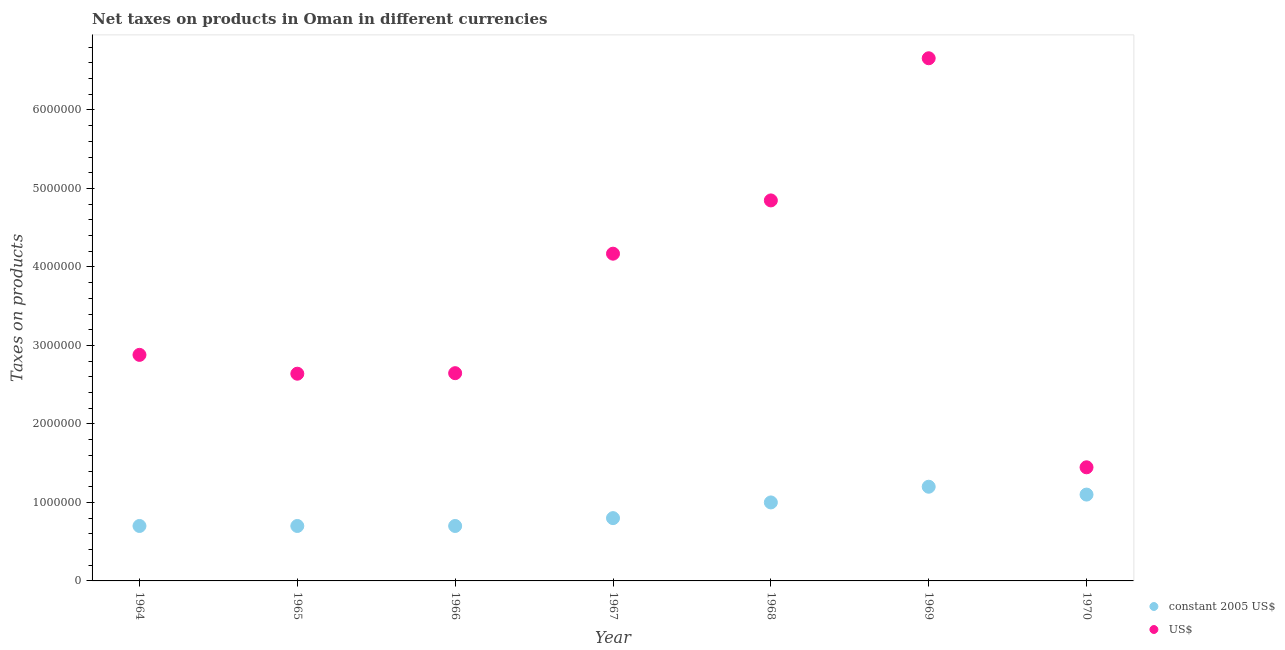Is the number of dotlines equal to the number of legend labels?
Keep it short and to the point. Yes. What is the net taxes in constant 2005 us$ in 1969?
Provide a short and direct response. 1.20e+06. Across all years, what is the maximum net taxes in constant 2005 us$?
Provide a short and direct response. 1.20e+06. Across all years, what is the minimum net taxes in us$?
Keep it short and to the point. 1.45e+06. In which year was the net taxes in constant 2005 us$ maximum?
Provide a succinct answer. 1969. In which year was the net taxes in constant 2005 us$ minimum?
Keep it short and to the point. 1964. What is the total net taxes in constant 2005 us$ in the graph?
Ensure brevity in your answer.  6.20e+06. What is the difference between the net taxes in constant 2005 us$ in 1966 and that in 1969?
Provide a succinct answer. -5.00e+05. What is the difference between the net taxes in us$ in 1968 and the net taxes in constant 2005 us$ in 1970?
Offer a terse response. 3.75e+06. What is the average net taxes in constant 2005 us$ per year?
Keep it short and to the point. 8.86e+05. In the year 1966, what is the difference between the net taxes in us$ and net taxes in constant 2005 us$?
Offer a very short reply. 1.95e+06. In how many years, is the net taxes in us$ greater than 4600000 units?
Your response must be concise. 2. What is the ratio of the net taxes in us$ in 1964 to that in 1968?
Your answer should be very brief. 0.59. Is the net taxes in constant 2005 us$ in 1965 less than that in 1970?
Give a very brief answer. Yes. Is the difference between the net taxes in us$ in 1966 and 1969 greater than the difference between the net taxes in constant 2005 us$ in 1966 and 1969?
Make the answer very short. No. What is the difference between the highest and the second highest net taxes in constant 2005 us$?
Keep it short and to the point. 1.00e+05. What is the difference between the highest and the lowest net taxes in us$?
Keep it short and to the point. 5.21e+06. Is the sum of the net taxes in us$ in 1968 and 1970 greater than the maximum net taxes in constant 2005 us$ across all years?
Ensure brevity in your answer.  Yes. Is the net taxes in constant 2005 us$ strictly less than the net taxes in us$ over the years?
Ensure brevity in your answer.  Yes. How many years are there in the graph?
Offer a terse response. 7. Does the graph contain grids?
Your response must be concise. No. What is the title of the graph?
Keep it short and to the point. Net taxes on products in Oman in different currencies. What is the label or title of the Y-axis?
Give a very brief answer. Taxes on products. What is the Taxes on products in US$ in 1964?
Offer a terse response. 2.88e+06. What is the Taxes on products in constant 2005 US$ in 1965?
Make the answer very short. 7.00e+05. What is the Taxes on products of US$ in 1965?
Your answer should be very brief. 2.64e+06. What is the Taxes on products of US$ in 1966?
Your answer should be compact. 2.65e+06. What is the Taxes on products in US$ in 1967?
Offer a very short reply. 4.17e+06. What is the Taxes on products of US$ in 1968?
Give a very brief answer. 4.85e+06. What is the Taxes on products of constant 2005 US$ in 1969?
Ensure brevity in your answer.  1.20e+06. What is the Taxes on products in US$ in 1969?
Your answer should be compact. 6.66e+06. What is the Taxes on products in constant 2005 US$ in 1970?
Provide a short and direct response. 1.10e+06. What is the Taxes on products in US$ in 1970?
Keep it short and to the point. 1.45e+06. Across all years, what is the maximum Taxes on products in constant 2005 US$?
Make the answer very short. 1.20e+06. Across all years, what is the maximum Taxes on products of US$?
Make the answer very short. 6.66e+06. Across all years, what is the minimum Taxes on products of constant 2005 US$?
Offer a very short reply. 7.00e+05. Across all years, what is the minimum Taxes on products of US$?
Make the answer very short. 1.45e+06. What is the total Taxes on products in constant 2005 US$ in the graph?
Provide a short and direct response. 6.20e+06. What is the total Taxes on products in US$ in the graph?
Your response must be concise. 2.53e+07. What is the difference between the Taxes on products in constant 2005 US$ in 1964 and that in 1965?
Your response must be concise. 0. What is the difference between the Taxes on products in US$ in 1964 and that in 1965?
Your answer should be very brief. 2.40e+05. What is the difference between the Taxes on products in US$ in 1964 and that in 1966?
Provide a short and direct response. 2.33e+05. What is the difference between the Taxes on products in US$ in 1964 and that in 1967?
Keep it short and to the point. -1.29e+06. What is the difference between the Taxes on products in US$ in 1964 and that in 1968?
Provide a short and direct response. -1.97e+06. What is the difference between the Taxes on products in constant 2005 US$ in 1964 and that in 1969?
Offer a very short reply. -5.00e+05. What is the difference between the Taxes on products of US$ in 1964 and that in 1969?
Give a very brief answer. -3.78e+06. What is the difference between the Taxes on products in constant 2005 US$ in 1964 and that in 1970?
Make the answer very short. -4.00e+05. What is the difference between the Taxes on products in US$ in 1964 and that in 1970?
Your response must be concise. 1.43e+06. What is the difference between the Taxes on products of US$ in 1965 and that in 1966?
Offer a terse response. -6816.09. What is the difference between the Taxes on products in US$ in 1965 and that in 1967?
Your answer should be very brief. -1.53e+06. What is the difference between the Taxes on products in constant 2005 US$ in 1965 and that in 1968?
Keep it short and to the point. -3.00e+05. What is the difference between the Taxes on products in US$ in 1965 and that in 1968?
Ensure brevity in your answer.  -2.21e+06. What is the difference between the Taxes on products of constant 2005 US$ in 1965 and that in 1969?
Your answer should be compact. -5.00e+05. What is the difference between the Taxes on products in US$ in 1965 and that in 1969?
Your answer should be very brief. -4.02e+06. What is the difference between the Taxes on products of constant 2005 US$ in 1965 and that in 1970?
Make the answer very short. -4.00e+05. What is the difference between the Taxes on products in US$ in 1965 and that in 1970?
Your answer should be compact. 1.19e+06. What is the difference between the Taxes on products of US$ in 1966 and that in 1967?
Provide a succinct answer. -1.52e+06. What is the difference between the Taxes on products in constant 2005 US$ in 1966 and that in 1968?
Provide a short and direct response. -3.00e+05. What is the difference between the Taxes on products of US$ in 1966 and that in 1968?
Your response must be concise. -2.20e+06. What is the difference between the Taxes on products of constant 2005 US$ in 1966 and that in 1969?
Your response must be concise. -5.00e+05. What is the difference between the Taxes on products of US$ in 1966 and that in 1969?
Provide a succinct answer. -4.01e+06. What is the difference between the Taxes on products in constant 2005 US$ in 1966 and that in 1970?
Offer a very short reply. -4.00e+05. What is the difference between the Taxes on products of US$ in 1966 and that in 1970?
Give a very brief answer. 1.20e+06. What is the difference between the Taxes on products in US$ in 1967 and that in 1968?
Your response must be concise. -6.79e+05. What is the difference between the Taxes on products in constant 2005 US$ in 1967 and that in 1969?
Make the answer very short. -4.00e+05. What is the difference between the Taxes on products of US$ in 1967 and that in 1969?
Ensure brevity in your answer.  -2.49e+06. What is the difference between the Taxes on products of US$ in 1967 and that in 1970?
Your response must be concise. 2.72e+06. What is the difference between the Taxes on products of US$ in 1968 and that in 1969?
Make the answer very short. -1.81e+06. What is the difference between the Taxes on products in US$ in 1968 and that in 1970?
Provide a succinct answer. 3.40e+06. What is the difference between the Taxes on products of US$ in 1969 and that in 1970?
Offer a terse response. 5.21e+06. What is the difference between the Taxes on products of constant 2005 US$ in 1964 and the Taxes on products of US$ in 1965?
Ensure brevity in your answer.  -1.94e+06. What is the difference between the Taxes on products in constant 2005 US$ in 1964 and the Taxes on products in US$ in 1966?
Keep it short and to the point. -1.95e+06. What is the difference between the Taxes on products of constant 2005 US$ in 1964 and the Taxes on products of US$ in 1967?
Make the answer very short. -3.47e+06. What is the difference between the Taxes on products in constant 2005 US$ in 1964 and the Taxes on products in US$ in 1968?
Your answer should be very brief. -4.15e+06. What is the difference between the Taxes on products of constant 2005 US$ in 1964 and the Taxes on products of US$ in 1969?
Provide a short and direct response. -5.96e+06. What is the difference between the Taxes on products in constant 2005 US$ in 1964 and the Taxes on products in US$ in 1970?
Give a very brief answer. -7.48e+05. What is the difference between the Taxes on products in constant 2005 US$ in 1965 and the Taxes on products in US$ in 1966?
Give a very brief answer. -1.95e+06. What is the difference between the Taxes on products in constant 2005 US$ in 1965 and the Taxes on products in US$ in 1967?
Offer a terse response. -3.47e+06. What is the difference between the Taxes on products of constant 2005 US$ in 1965 and the Taxes on products of US$ in 1968?
Make the answer very short. -4.15e+06. What is the difference between the Taxes on products in constant 2005 US$ in 1965 and the Taxes on products in US$ in 1969?
Provide a succinct answer. -5.96e+06. What is the difference between the Taxes on products of constant 2005 US$ in 1965 and the Taxes on products of US$ in 1970?
Your answer should be very brief. -7.48e+05. What is the difference between the Taxes on products in constant 2005 US$ in 1966 and the Taxes on products in US$ in 1967?
Keep it short and to the point. -3.47e+06. What is the difference between the Taxes on products in constant 2005 US$ in 1966 and the Taxes on products in US$ in 1968?
Keep it short and to the point. -4.15e+06. What is the difference between the Taxes on products of constant 2005 US$ in 1966 and the Taxes on products of US$ in 1969?
Offer a very short reply. -5.96e+06. What is the difference between the Taxes on products in constant 2005 US$ in 1966 and the Taxes on products in US$ in 1970?
Your answer should be very brief. -7.48e+05. What is the difference between the Taxes on products in constant 2005 US$ in 1967 and the Taxes on products in US$ in 1968?
Offer a terse response. -4.05e+06. What is the difference between the Taxes on products in constant 2005 US$ in 1967 and the Taxes on products in US$ in 1969?
Ensure brevity in your answer.  -5.86e+06. What is the difference between the Taxes on products in constant 2005 US$ in 1967 and the Taxes on products in US$ in 1970?
Give a very brief answer. -6.48e+05. What is the difference between the Taxes on products in constant 2005 US$ in 1968 and the Taxes on products in US$ in 1969?
Ensure brevity in your answer.  -5.66e+06. What is the difference between the Taxes on products in constant 2005 US$ in 1968 and the Taxes on products in US$ in 1970?
Ensure brevity in your answer.  -4.48e+05. What is the difference between the Taxes on products in constant 2005 US$ in 1969 and the Taxes on products in US$ in 1970?
Provide a short and direct response. -2.48e+05. What is the average Taxes on products of constant 2005 US$ per year?
Provide a succinct answer. 8.86e+05. What is the average Taxes on products of US$ per year?
Your answer should be compact. 3.61e+06. In the year 1964, what is the difference between the Taxes on products in constant 2005 US$ and Taxes on products in US$?
Your response must be concise. -2.18e+06. In the year 1965, what is the difference between the Taxes on products of constant 2005 US$ and Taxes on products of US$?
Offer a terse response. -1.94e+06. In the year 1966, what is the difference between the Taxes on products of constant 2005 US$ and Taxes on products of US$?
Provide a short and direct response. -1.95e+06. In the year 1967, what is the difference between the Taxes on products in constant 2005 US$ and Taxes on products in US$?
Ensure brevity in your answer.  -3.37e+06. In the year 1968, what is the difference between the Taxes on products in constant 2005 US$ and Taxes on products in US$?
Provide a short and direct response. -3.85e+06. In the year 1969, what is the difference between the Taxes on products in constant 2005 US$ and Taxes on products in US$?
Your answer should be very brief. -5.46e+06. In the year 1970, what is the difference between the Taxes on products of constant 2005 US$ and Taxes on products of US$?
Your response must be concise. -3.48e+05. What is the ratio of the Taxes on products of US$ in 1964 to that in 1965?
Offer a very short reply. 1.09. What is the ratio of the Taxes on products of US$ in 1964 to that in 1966?
Provide a short and direct response. 1.09. What is the ratio of the Taxes on products in constant 2005 US$ in 1964 to that in 1967?
Make the answer very short. 0.88. What is the ratio of the Taxes on products in US$ in 1964 to that in 1967?
Your answer should be compact. 0.69. What is the ratio of the Taxes on products in US$ in 1964 to that in 1968?
Provide a succinct answer. 0.59. What is the ratio of the Taxes on products of constant 2005 US$ in 1964 to that in 1969?
Ensure brevity in your answer.  0.58. What is the ratio of the Taxes on products of US$ in 1964 to that in 1969?
Your answer should be compact. 0.43. What is the ratio of the Taxes on products of constant 2005 US$ in 1964 to that in 1970?
Give a very brief answer. 0.64. What is the ratio of the Taxes on products of US$ in 1964 to that in 1970?
Make the answer very short. 1.99. What is the ratio of the Taxes on products of constant 2005 US$ in 1965 to that in 1967?
Your answer should be compact. 0.88. What is the ratio of the Taxes on products of US$ in 1965 to that in 1967?
Provide a succinct answer. 0.63. What is the ratio of the Taxes on products of constant 2005 US$ in 1965 to that in 1968?
Give a very brief answer. 0.7. What is the ratio of the Taxes on products of US$ in 1965 to that in 1968?
Provide a short and direct response. 0.54. What is the ratio of the Taxes on products in constant 2005 US$ in 1965 to that in 1969?
Provide a short and direct response. 0.58. What is the ratio of the Taxes on products in US$ in 1965 to that in 1969?
Your answer should be compact. 0.4. What is the ratio of the Taxes on products of constant 2005 US$ in 1965 to that in 1970?
Your response must be concise. 0.64. What is the ratio of the Taxes on products in US$ in 1965 to that in 1970?
Give a very brief answer. 1.82. What is the ratio of the Taxes on products of constant 2005 US$ in 1966 to that in 1967?
Make the answer very short. 0.88. What is the ratio of the Taxes on products of US$ in 1966 to that in 1967?
Ensure brevity in your answer.  0.63. What is the ratio of the Taxes on products of constant 2005 US$ in 1966 to that in 1968?
Ensure brevity in your answer.  0.7. What is the ratio of the Taxes on products in US$ in 1966 to that in 1968?
Your response must be concise. 0.55. What is the ratio of the Taxes on products of constant 2005 US$ in 1966 to that in 1969?
Your answer should be very brief. 0.58. What is the ratio of the Taxes on products of US$ in 1966 to that in 1969?
Keep it short and to the point. 0.4. What is the ratio of the Taxes on products in constant 2005 US$ in 1966 to that in 1970?
Offer a terse response. 0.64. What is the ratio of the Taxes on products in US$ in 1966 to that in 1970?
Ensure brevity in your answer.  1.83. What is the ratio of the Taxes on products in US$ in 1967 to that in 1968?
Your answer should be compact. 0.86. What is the ratio of the Taxes on products in US$ in 1967 to that in 1969?
Offer a terse response. 0.63. What is the ratio of the Taxes on products of constant 2005 US$ in 1967 to that in 1970?
Provide a succinct answer. 0.73. What is the ratio of the Taxes on products of US$ in 1967 to that in 1970?
Ensure brevity in your answer.  2.88. What is the ratio of the Taxes on products of constant 2005 US$ in 1968 to that in 1969?
Provide a short and direct response. 0.83. What is the ratio of the Taxes on products of US$ in 1968 to that in 1969?
Your answer should be compact. 0.73. What is the ratio of the Taxes on products in constant 2005 US$ in 1968 to that in 1970?
Your answer should be very brief. 0.91. What is the ratio of the Taxes on products of US$ in 1968 to that in 1970?
Your answer should be very brief. 3.35. What is the ratio of the Taxes on products in constant 2005 US$ in 1969 to that in 1970?
Your answer should be compact. 1.09. What is the ratio of the Taxes on products in US$ in 1969 to that in 1970?
Your response must be concise. 4.6. What is the difference between the highest and the second highest Taxes on products in US$?
Your response must be concise. 1.81e+06. What is the difference between the highest and the lowest Taxes on products of US$?
Make the answer very short. 5.21e+06. 